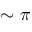<formula> <loc_0><loc_0><loc_500><loc_500>\sim \pi</formula> 